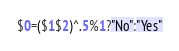<code> <loc_0><loc_0><loc_500><loc_500><_Awk_>$0=($1$2)^.5%1?"No":"Yes"</code> 